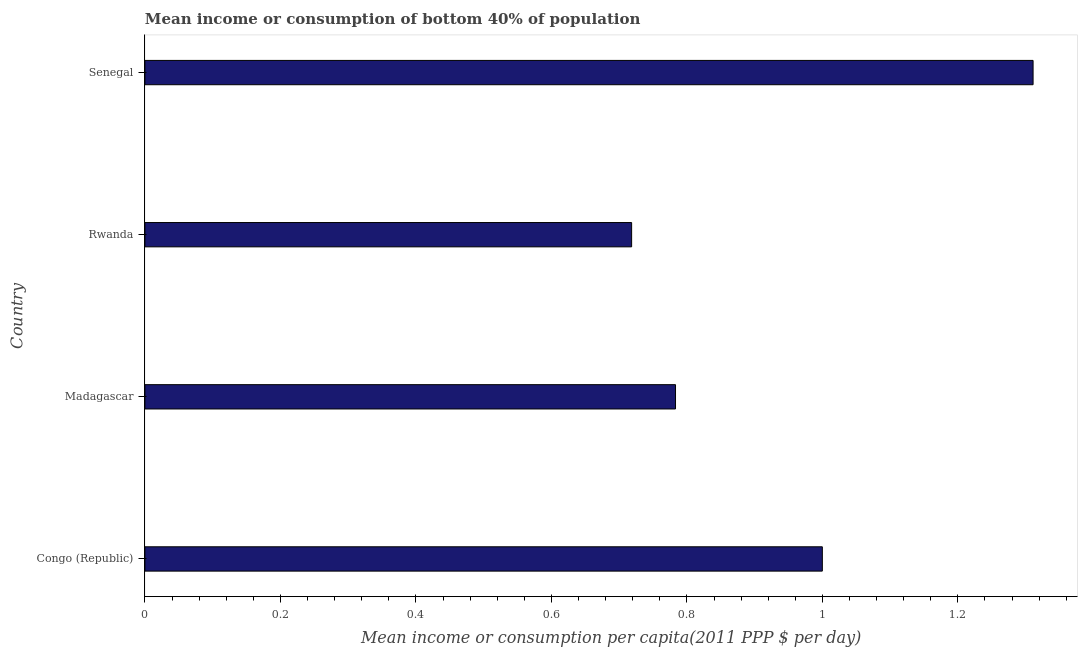What is the title of the graph?
Your answer should be very brief. Mean income or consumption of bottom 40% of population. What is the label or title of the X-axis?
Your response must be concise. Mean income or consumption per capita(2011 PPP $ per day). What is the label or title of the Y-axis?
Your answer should be very brief. Country. What is the mean income or consumption in Congo (Republic)?
Offer a terse response. 1. Across all countries, what is the maximum mean income or consumption?
Provide a succinct answer. 1.31. Across all countries, what is the minimum mean income or consumption?
Make the answer very short. 0.72. In which country was the mean income or consumption maximum?
Offer a very short reply. Senegal. In which country was the mean income or consumption minimum?
Provide a succinct answer. Rwanda. What is the sum of the mean income or consumption?
Your response must be concise. 3.81. What is the difference between the mean income or consumption in Madagascar and Senegal?
Offer a terse response. -0.53. What is the average mean income or consumption per country?
Provide a succinct answer. 0.95. What is the median mean income or consumption?
Provide a succinct answer. 0.89. What is the ratio of the mean income or consumption in Congo (Republic) to that in Madagascar?
Provide a short and direct response. 1.28. Is the mean income or consumption in Congo (Republic) less than that in Rwanda?
Your answer should be very brief. No. What is the difference between the highest and the second highest mean income or consumption?
Your response must be concise. 0.31. What is the difference between the highest and the lowest mean income or consumption?
Your answer should be compact. 0.59. Are all the bars in the graph horizontal?
Ensure brevity in your answer.  Yes. How many countries are there in the graph?
Provide a short and direct response. 4. Are the values on the major ticks of X-axis written in scientific E-notation?
Your answer should be very brief. No. What is the Mean income or consumption per capita(2011 PPP $ per day) in Congo (Republic)?
Provide a succinct answer. 1. What is the Mean income or consumption per capita(2011 PPP $ per day) in Madagascar?
Your answer should be very brief. 0.78. What is the Mean income or consumption per capita(2011 PPP $ per day) of Rwanda?
Your answer should be compact. 0.72. What is the Mean income or consumption per capita(2011 PPP $ per day) in Senegal?
Offer a terse response. 1.31. What is the difference between the Mean income or consumption per capita(2011 PPP $ per day) in Congo (Republic) and Madagascar?
Provide a short and direct response. 0.22. What is the difference between the Mean income or consumption per capita(2011 PPP $ per day) in Congo (Republic) and Rwanda?
Keep it short and to the point. 0.28. What is the difference between the Mean income or consumption per capita(2011 PPP $ per day) in Congo (Republic) and Senegal?
Offer a terse response. -0.31. What is the difference between the Mean income or consumption per capita(2011 PPP $ per day) in Madagascar and Rwanda?
Provide a succinct answer. 0.06. What is the difference between the Mean income or consumption per capita(2011 PPP $ per day) in Madagascar and Senegal?
Your answer should be very brief. -0.53. What is the difference between the Mean income or consumption per capita(2011 PPP $ per day) in Rwanda and Senegal?
Make the answer very short. -0.59. What is the ratio of the Mean income or consumption per capita(2011 PPP $ per day) in Congo (Republic) to that in Madagascar?
Provide a succinct answer. 1.28. What is the ratio of the Mean income or consumption per capita(2011 PPP $ per day) in Congo (Republic) to that in Rwanda?
Give a very brief answer. 1.39. What is the ratio of the Mean income or consumption per capita(2011 PPP $ per day) in Congo (Republic) to that in Senegal?
Your answer should be very brief. 0.76. What is the ratio of the Mean income or consumption per capita(2011 PPP $ per day) in Madagascar to that in Rwanda?
Your response must be concise. 1.09. What is the ratio of the Mean income or consumption per capita(2011 PPP $ per day) in Madagascar to that in Senegal?
Keep it short and to the point. 0.6. What is the ratio of the Mean income or consumption per capita(2011 PPP $ per day) in Rwanda to that in Senegal?
Offer a very short reply. 0.55. 